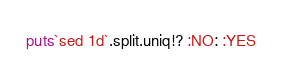Convert code to text. <code><loc_0><loc_0><loc_500><loc_500><_Ruby_>puts`sed 1d`.split.uniq!? :NO: :YES</code> 